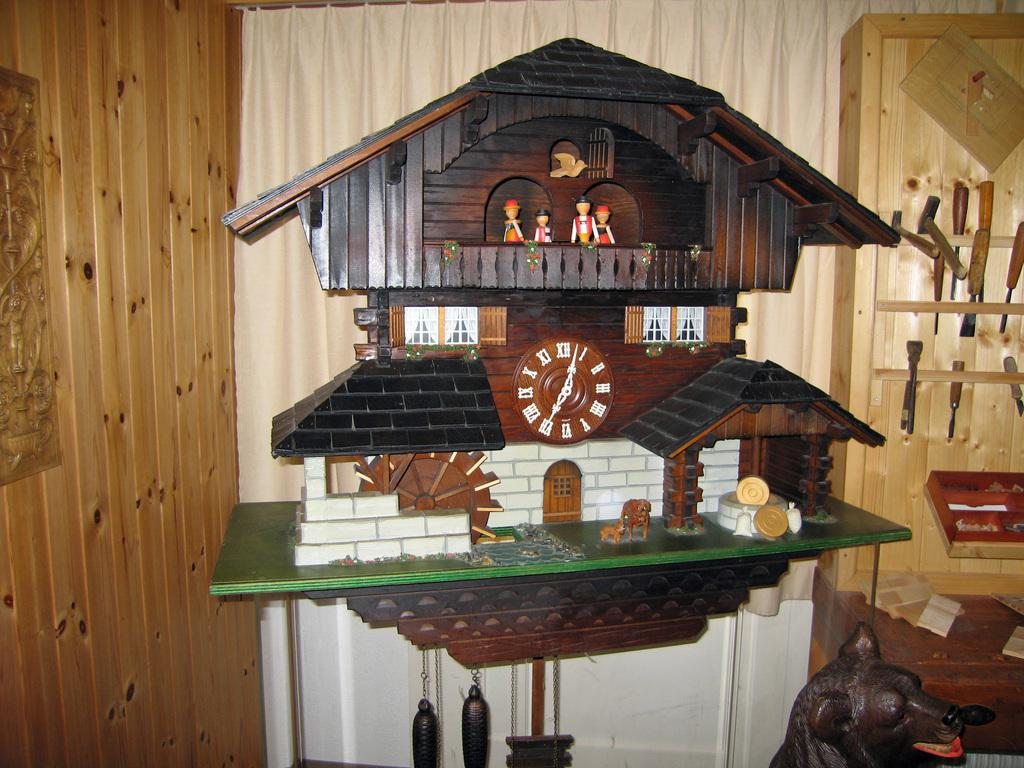<image>
Render a clear and concise summary of the photo. A black forest style cuckoo clock has the numeral XII at the top of the dial. 